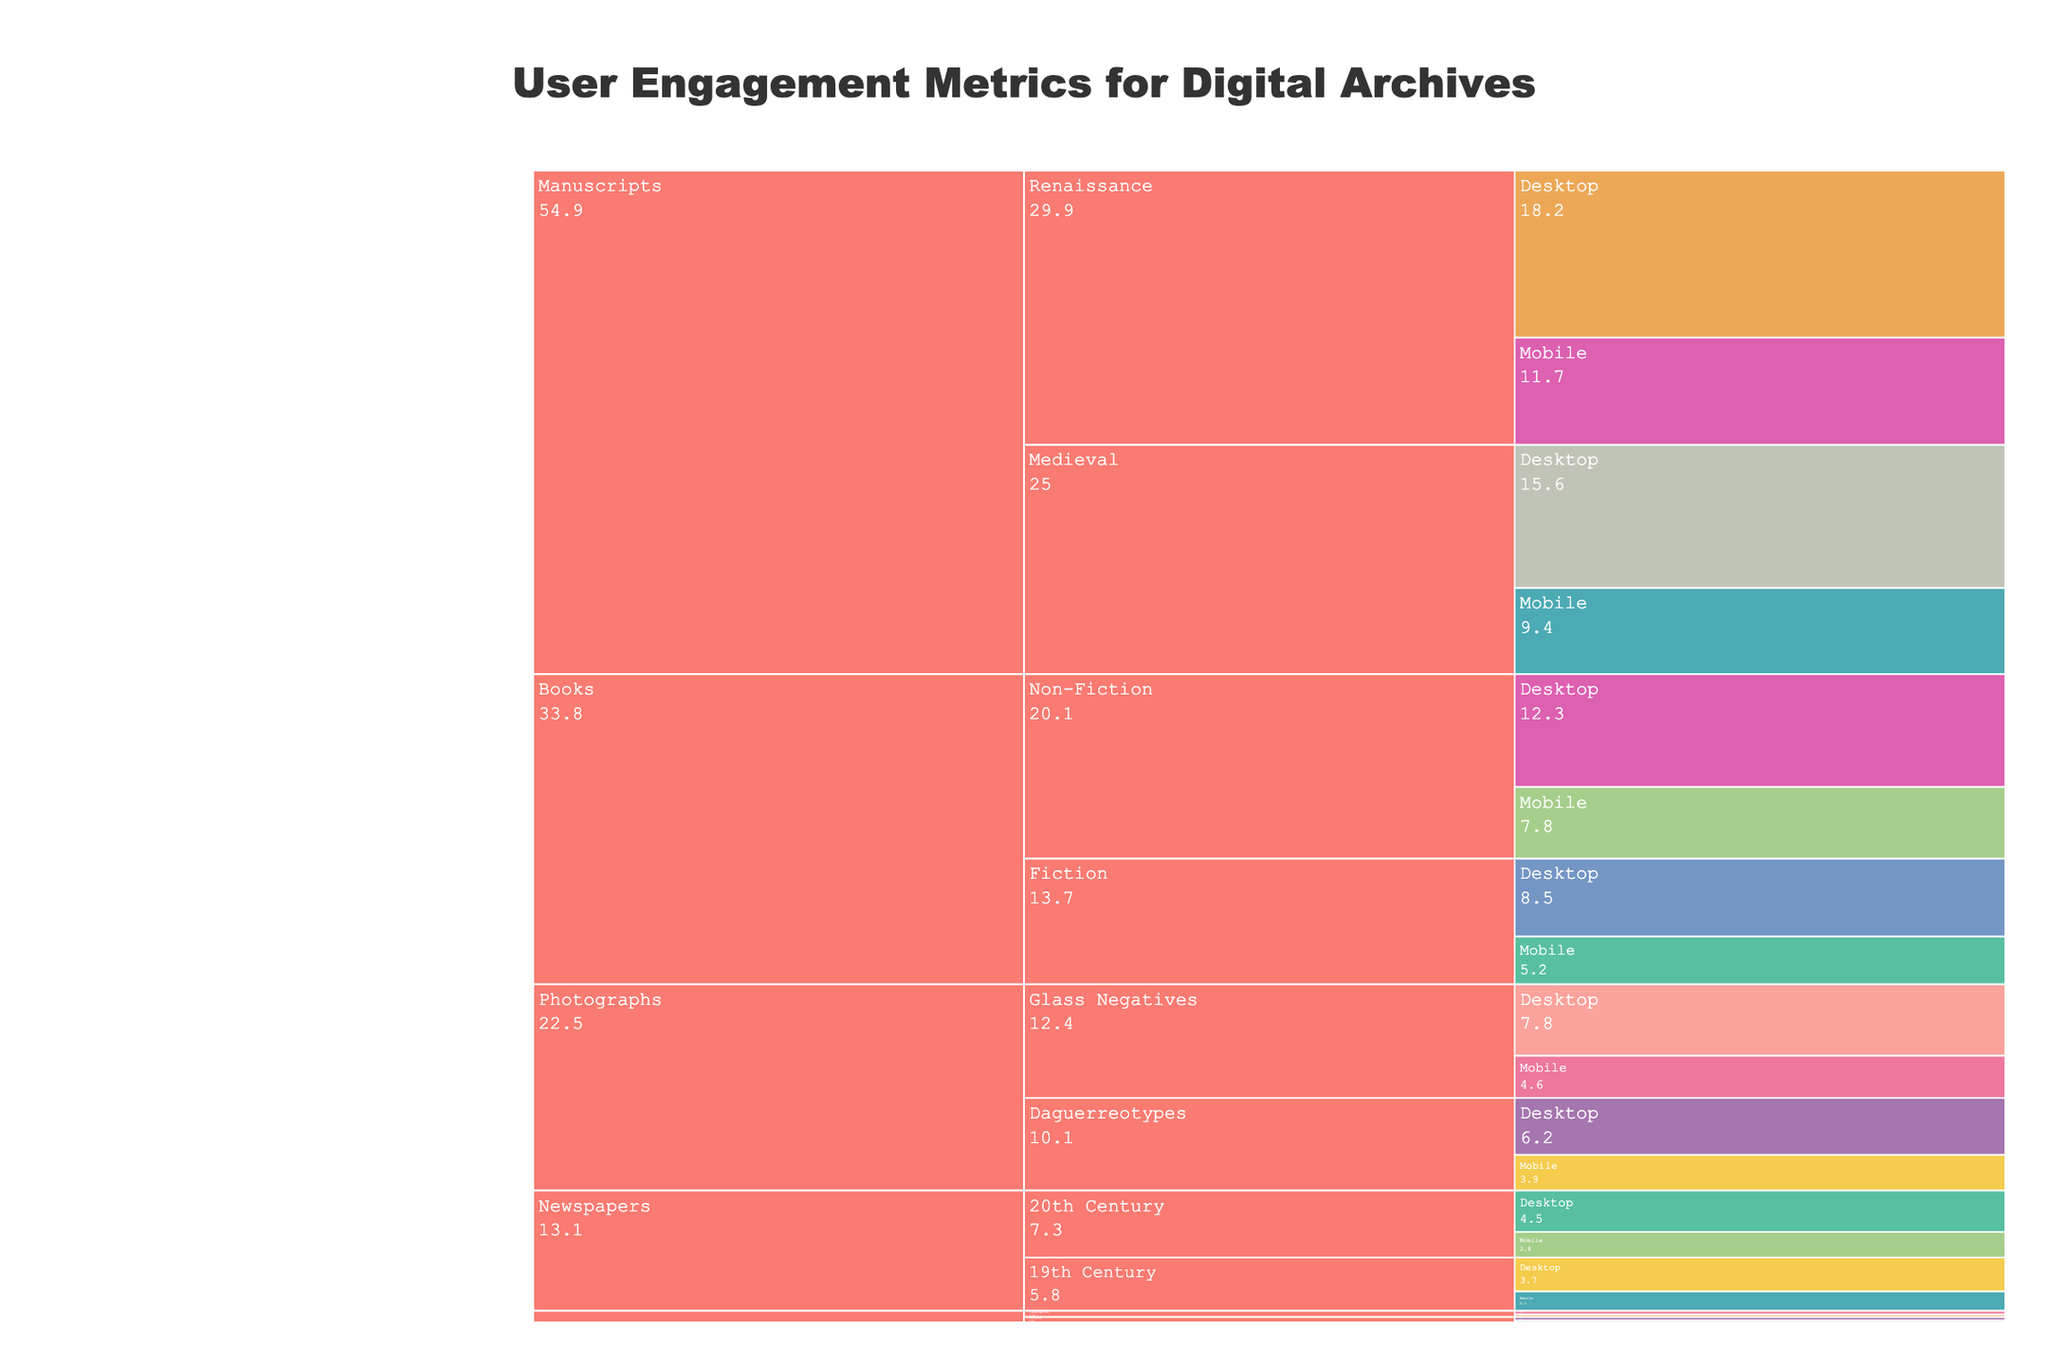What is the title of the chart? The title is at the top of the chart. It reads: "User Engagement Metrics for Digital Archives."
Answer: User Engagement Metrics for Digital Archives Which category has the highest number of values? By observing the branches of the Icicle Chart, we can see that the longest branch (most values) is from the 'Books' category.
Answer: Books What is the engagement metric for 'Non-Fiction' books accessed via Desktop? Locate the 'Books' category, then its 'Non-Fiction' subcategory, and find the branch for 'Desktop.' The engagement metric is 'Average Session Duration' with a value of 12.3.
Answer: Average Session Duration Which access method has the lower value for 'Time on Page' in the '19th Century' Newspapers? Within the 'Newspapers' category, navigate to '19th Century' subcategory and compare 'Desktop' and 'Mobile' branches. 'Mobile' has a value of 2.1 which is lower than 'Desktop' with 3.7.
Answer: Mobile What is the sum of 'Average Session Duration' values for 'Fiction' Books accessed via both Desktop and Mobile? Add the values for 'Desktop' and 'Mobile' under 'Fiction' in the 'Books' category. The values are 8.5 and 5.2 respectively. Therefore, the sum is 8.5 + 5.2 = 13.7.
Answer: 13.7 Which subcategory in 'Manuscripts' has higher 'Pages Viewed' on Desktop? Compare 'Medieval' and 'Renaissance' subcategories under 'Manuscripts' using the 'Desktop' branch. 'Renaissance' has a higher value (18.2) compared to 'Medieval' (15.6).
Answer: Renaissance What's the difference in 'Zoom Interactions' for 'Daguerreotypes' Photographs between Desktop and Mobile access methods? Look under 'Photographs' category for 'Daguerreotypes' and subtract the 'Mobile' value from the 'Desktop' value: 6.2 - 3.9 = 2.3.
Answer: 2.3 Which 'Topographical' Maps access method has a higher Download Rate? Check the 'Topographical' subcategory in 'Maps' and compare the 'Desktop' and 'Mobile' values. 'Desktop' has a higher Download Rate (0.41) compared to 'Mobile' (0.28).
Answer: Desktop 